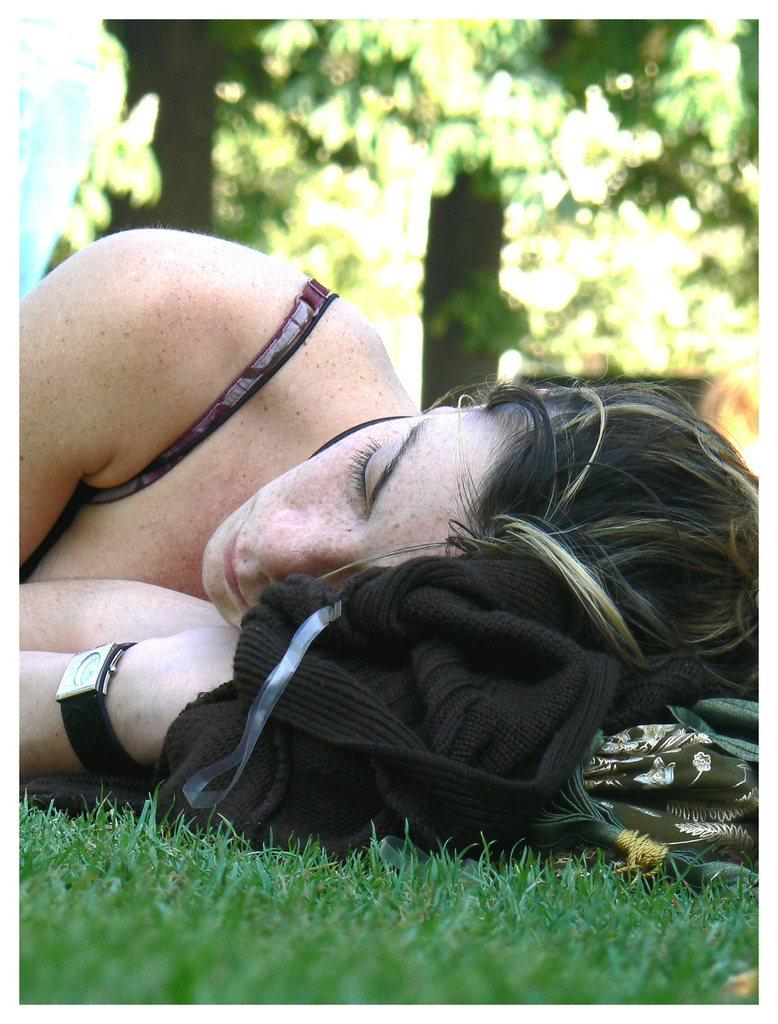What type of vegetation is at the bottom of the image? There is grass at the bottom of the image. What is the woman doing in the image? The woman is lying above the grass. What can be seen in the background of the image? There are trees visible behind the woman. What type of grape is the woman eating in the image? There is no grape present in the image, and the woman is not eating anything. What activity is the woman participating in during this particular week? The image does not provide information about the week or any specific activity the woman is engaged in. 